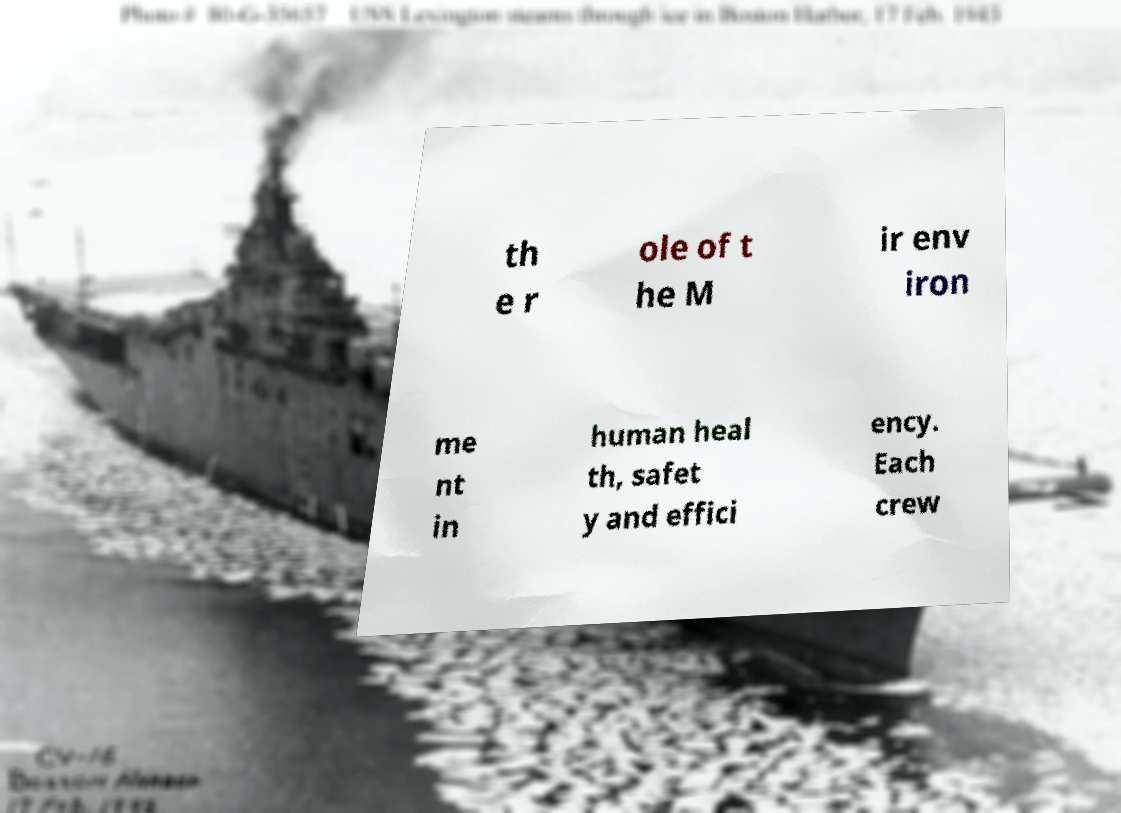For documentation purposes, I need the text within this image transcribed. Could you provide that? th e r ole of t he M ir env iron me nt in human heal th, safet y and effici ency. Each crew 